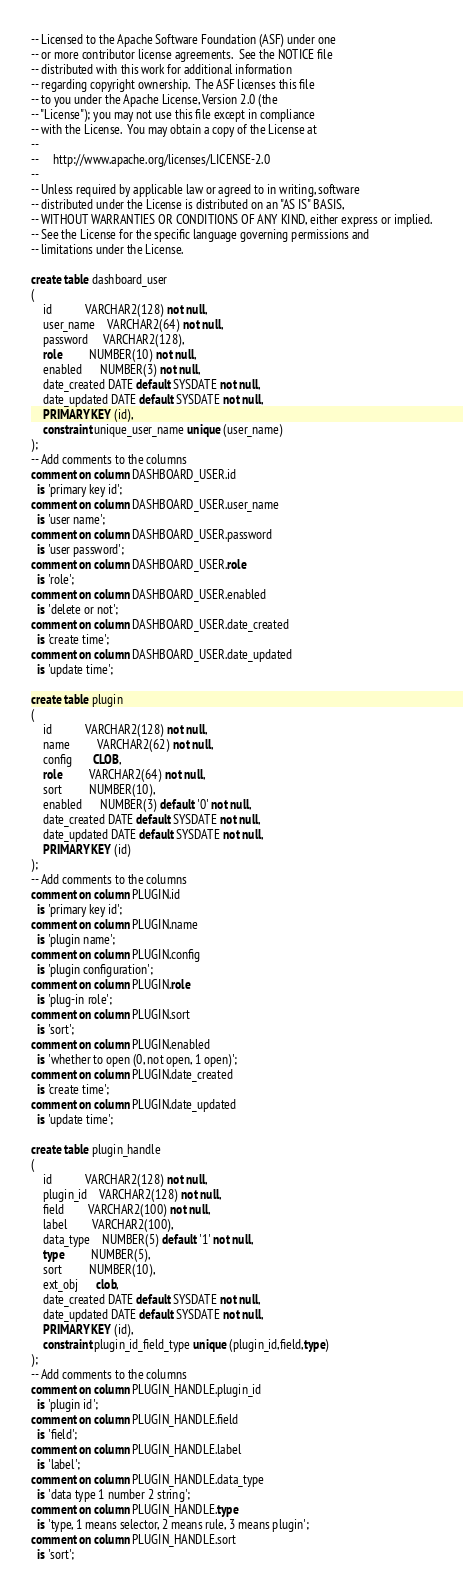<code> <loc_0><loc_0><loc_500><loc_500><_SQL_>-- Licensed to the Apache Software Foundation (ASF) under one
-- or more contributor license agreements.  See the NOTICE file
-- distributed with this work for additional information
-- regarding copyright ownership.  The ASF licenses this file
-- to you under the Apache License, Version 2.0 (the
-- "License"); you may not use this file except in compliance
-- with the License.  You may obtain a copy of the License at
--
--     http://www.apache.org/licenses/LICENSE-2.0
--
-- Unless required by applicable law or agreed to in writing, software
-- distributed under the License is distributed on an "AS IS" BASIS,
-- WITHOUT WARRANTIES OR CONDITIONS OF ANY KIND, either express or implied.
-- See the License for the specific language governing permissions and
-- limitations under the License.

create table dashboard_user
(
    id           VARCHAR2(128) not null,
    user_name    VARCHAR2(64) not null,
    password     VARCHAR2(128),
    role         NUMBER(10) not null,
    enabled      NUMBER(3) not null,
    date_created DATE default SYSDATE not null,
    date_updated DATE default SYSDATE not null,
    PRIMARY KEY (id),
    constraint unique_user_name unique (user_name)
);
-- Add comments to the columns
comment on column DASHBOARD_USER.id
  is 'primary key id';
comment on column DASHBOARD_USER.user_name
  is 'user name';
comment on column DASHBOARD_USER.password
  is 'user password';
comment on column DASHBOARD_USER.role
  is 'role';
comment on column DASHBOARD_USER.enabled
  is 'delete or not';
comment on column DASHBOARD_USER.date_created
  is 'create time';
comment on column DASHBOARD_USER.date_updated
  is 'update time';

create table plugin
(
    id           VARCHAR2(128) not null,
    name         VARCHAR2(62) not null,
    config       CLOB,
    role         VARCHAR2(64) not null,
    sort         NUMBER(10),
    enabled      NUMBER(3) default '0' not null,
    date_created DATE default SYSDATE not null,
    date_updated DATE default SYSDATE not null,
    PRIMARY KEY (id)
);
-- Add comments to the columns
comment on column PLUGIN.id
  is 'primary key id';
comment on column PLUGIN.name
  is 'plugin name';
comment on column PLUGIN.config
  is 'plugin configuration';
comment on column PLUGIN.role
  is 'plug-in role';
comment on column PLUGIN.sort
  is 'sort';
comment on column PLUGIN.enabled
  is 'whether to open (0, not open, 1 open)';
comment on column PLUGIN.date_created
  is 'create time';
comment on column PLUGIN.date_updated
  is 'update time';

create table plugin_handle
(
    id           VARCHAR2(128) not null,
    plugin_id    VARCHAR2(128) not null,
    field        VARCHAR2(100) not null,
    label        VARCHAR2(100),
    data_type    NUMBER(5) default '1' not null,
    type         NUMBER(5),
    sort         NUMBER(10),
    ext_obj      clob,
    date_created DATE default SYSDATE not null,
    date_updated DATE default SYSDATE not null,
    PRIMARY KEY (id),
    constraint plugin_id_field_type unique (plugin_id,field,type)
);
-- Add comments to the columns
comment on column PLUGIN_HANDLE.plugin_id
  is 'plugin id';
comment on column PLUGIN_HANDLE.field
  is 'field';
comment on column PLUGIN_HANDLE.label
  is 'label';
comment on column PLUGIN_HANDLE.data_type
  is 'data type 1 number 2 string';
comment on column PLUGIN_HANDLE.type
  is 'type, 1 means selector, 2 means rule, 3 means plugin';
comment on column PLUGIN_HANDLE.sort
  is 'sort';</code> 